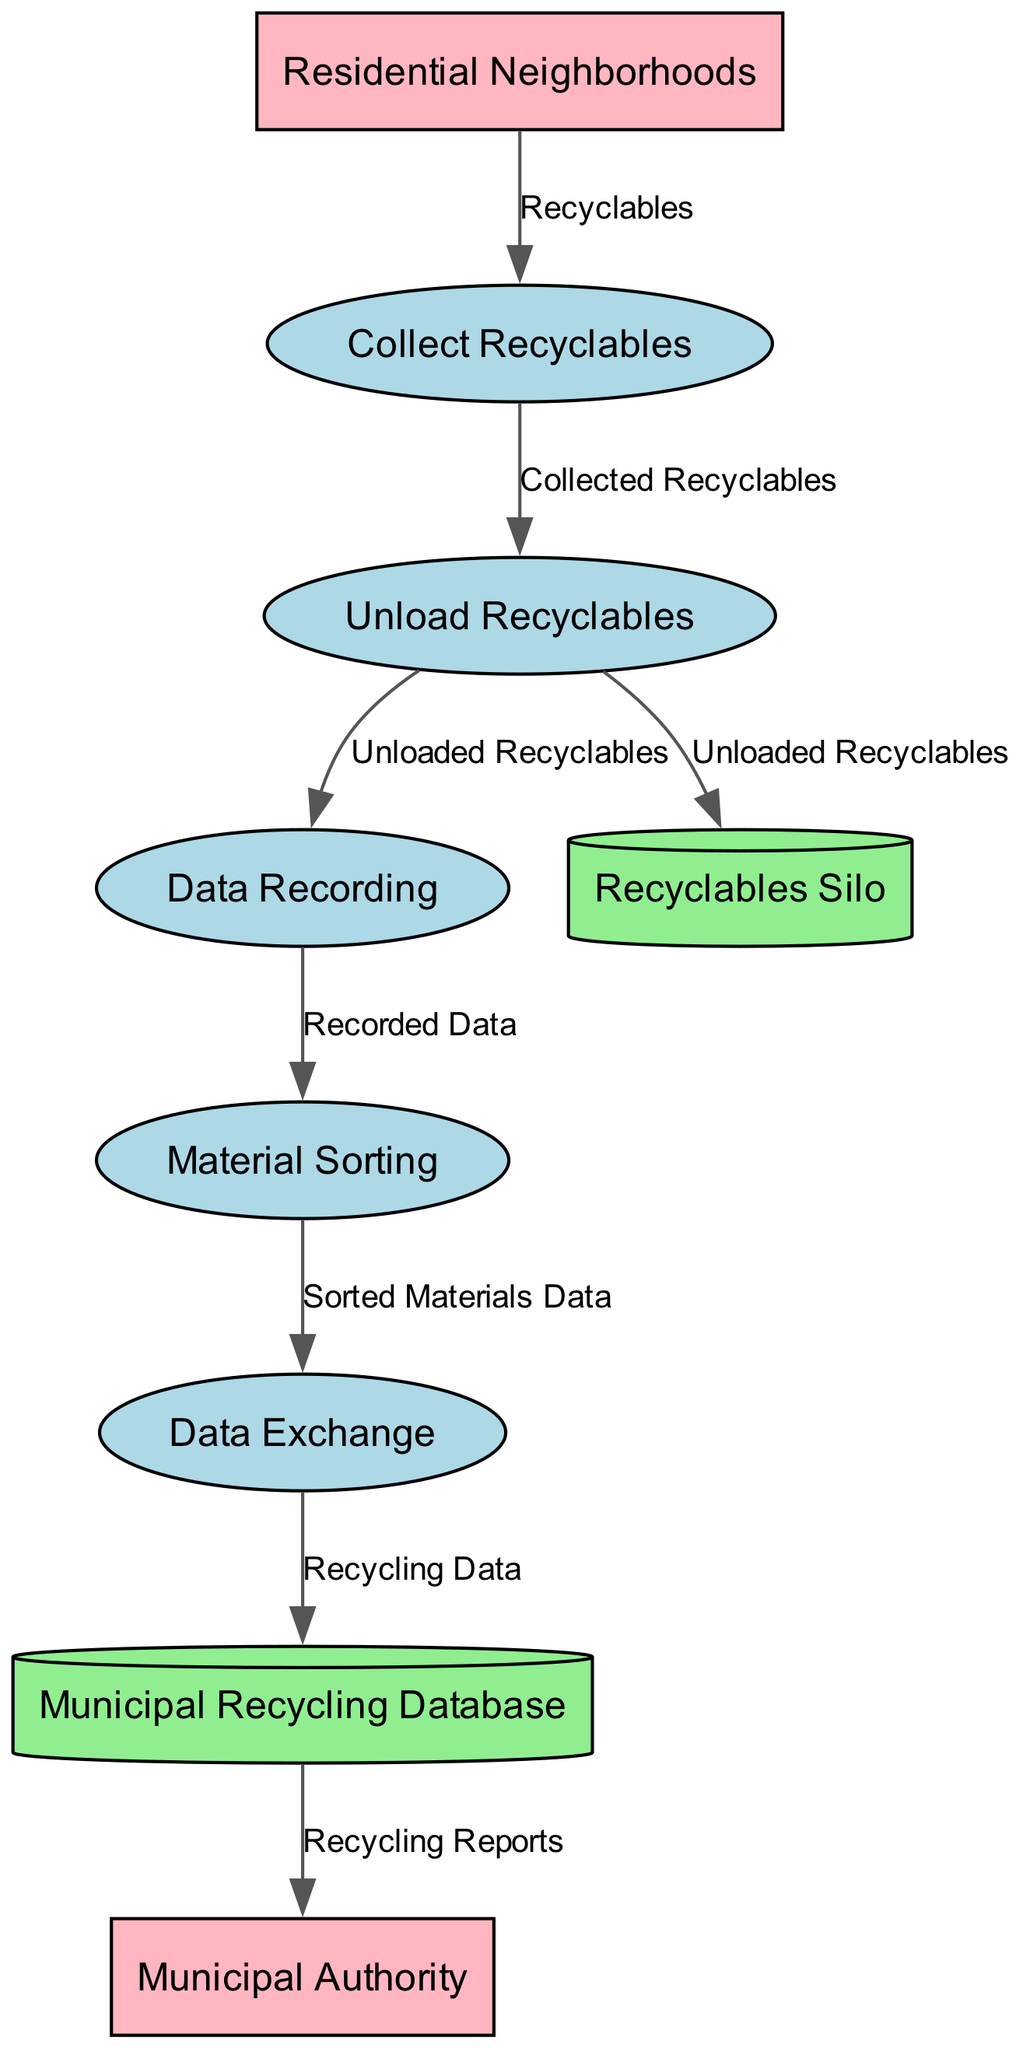What is the first process in the diagram? The first process listed in the diagram is "Collect Recyclables", which corresponds to the recycling truck driver collecting recyclables from residential neighborhoods.
Answer: Collect Re recyclables What type of data does the sorting facility recording process capture? The "Data Recording" process captures data about the collected recyclables, which includes the type and weight of the materials.
Answer: Type and weight How many data stores are depicted in the diagram? There are two data stores shown in the diagram: "Recyclables Silo" and "Municipal Recycling Database".
Answer: 2 Which external entity provides the recyclables? The external entity that provides the recyclables is "Residential Neighborhoods", as noted in the diagram's connections.
Answer: Residential Neighborhoods What is the final process related to data exchange in the sorting facility? The final process related to data exchange is "Data Exchange", which sends data regarding sorted materials to the municipal recycling database.
Answer: Data Exchange What flows from the "Material Sorting" process to the "Data Exchange" process? The data that flows from the "Material Sorting" process to the "Data Exchange" process is "Sorted Materials Data", indicating the transfer of sorted material information.
Answer: Sorted Materials Data Which process involves unloading recyclables? The process that involves unloading recyclables is "Unload Recyclables", where the recycling truck driver unloads collected recyclables at the sorting facility.
Answer: Unload Recyclables What type of diagram is this? This is a Data Flow Diagram, characterized by its representation of processes, data flows, data stores, and external entities involved in the recycling operations.
Answer: Data Flow Diagram 